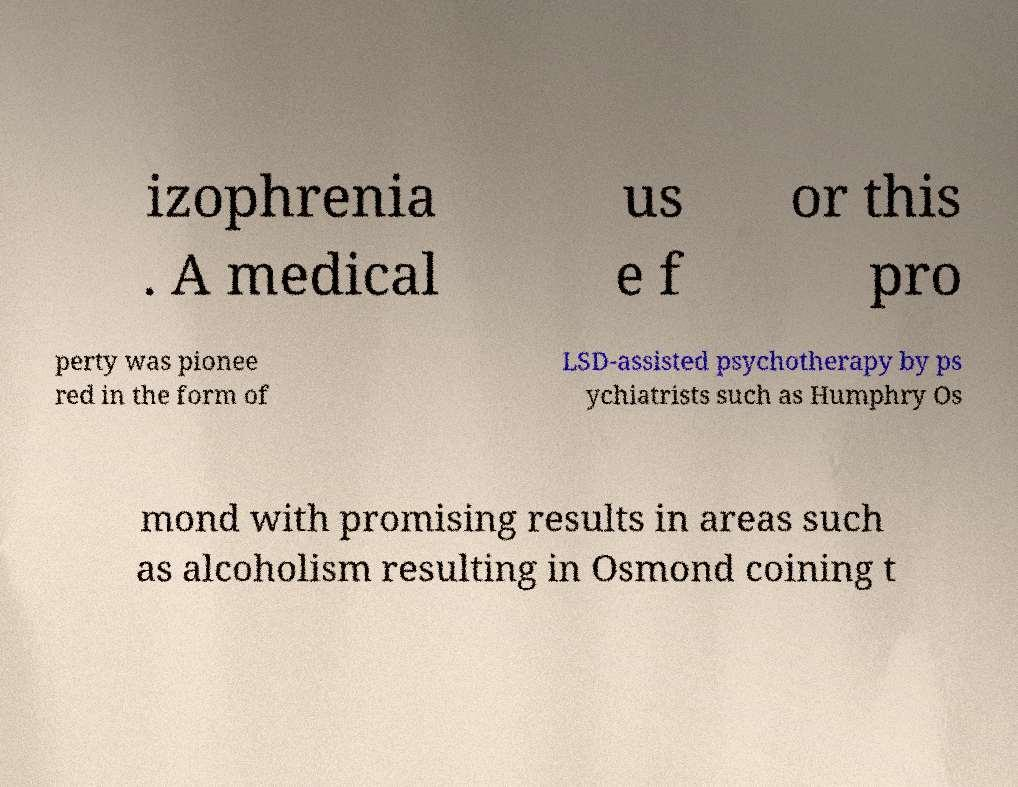Can you read and provide the text displayed in the image?This photo seems to have some interesting text. Can you extract and type it out for me? izophrenia . A medical us e f or this pro perty was pionee red in the form of LSD-assisted psychotherapy by ps ychiatrists such as Humphry Os mond with promising results in areas such as alcoholism resulting in Osmond coining t 